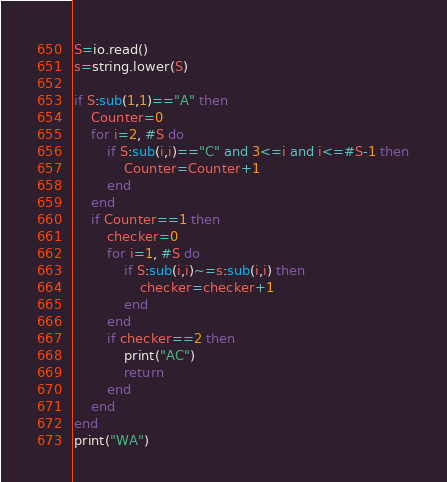<code> <loc_0><loc_0><loc_500><loc_500><_Lua_>S=io.read()
s=string.lower(S)

if S:sub(1,1)=="A" then
    Counter=0
    for i=2, #S do
        if S:sub(i,i)=="C" and 3<=i and i<=#S-1 then
            Counter=Counter+1
        end
    end
    if Counter==1 then
        checker=0
        for i=1, #S do
            if S:sub(i,i)~=s:sub(i,i) then
                checker=checker+1
            end
        end
        if checker==2 then
            print("AC")
            return
        end
    end
end
print("WA")</code> 